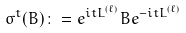<formula> <loc_0><loc_0><loc_500><loc_500>\sigma ^ { t } ( B ) \colon = e ^ { i t L ^ { ( \ell ) } } B e ^ { - i t L ^ { ( \ell ) } }</formula> 